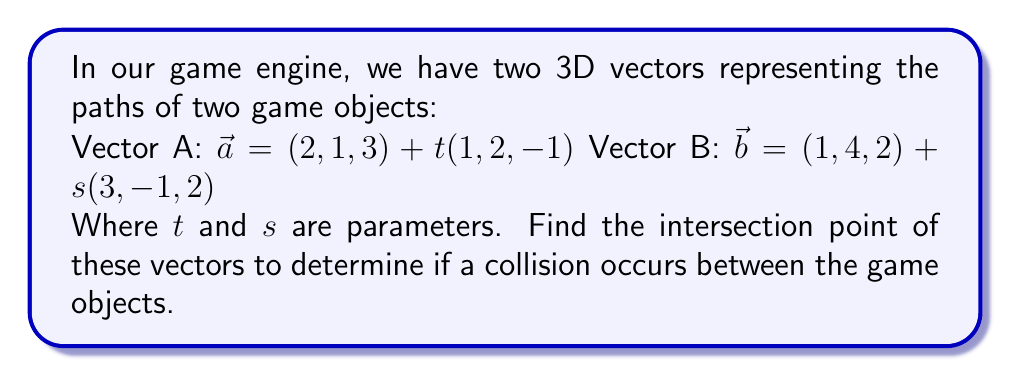Solve this math problem. To find the intersection point, we need to solve the equation:

$$(2, 1, 3) + t(1, 2, -1) = (1, 4, 2) + s(3, -1, 2)$$

This gives us three equations:

1) $2 + t = 1 + 3s$
2) $1 + 2t = 4 - s$
3) $3 - t = 2 + 2s$

From equation 1:
$$t = -1 + 3s \quad (4)$$

Substituting (4) into equation 2:
$$1 + 2(-1 + 3s) = 4 - s$$
$$1 - 2 + 6s = 4 - s$$
$$6s + s = 4 - 1 + 2$$
$$7s = 5$$
$$s = \frac{5}{7}$$

Substituting $s = \frac{5}{7}$ into (4):
$$t = -1 + 3(\frac{5}{7}) = -1 + \frac{15}{7} = \frac{8}{7}$$

We can verify these values satisfy equation 3:

$$3 - \frac{8}{7} = 2 + 2(\frac{5}{7})$$
$$\frac{21}{7} - \frac{8}{7} = \frac{14}{7} + \frac{10}{7}$$
$$\frac{13}{7} = \frac{24}{7}$$

The equation is satisfied, confirming our solution.

Now, we can find the intersection point by substituting $t = \frac{8}{7}$ into vector A:

$$\vec{a} = (2, 1, 3) + \frac{8}{7}(1, 2, -1)$$
$$= (2, 1, 3) + (\frac{8}{7}, \frac{16}{7}, -\frac{8}{7})$$
$$= (\frac{22}{7}, \frac{23}{7}, \frac{13}{7})$$
Answer: $(\frac{22}{7}, \frac{23}{7}, \frac{13}{7})$ 